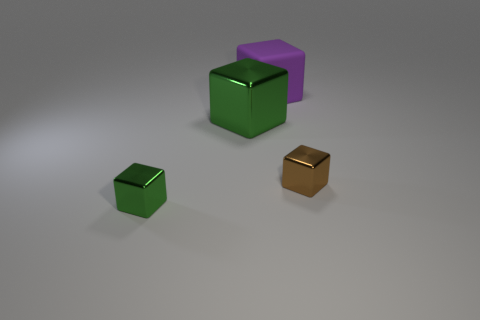Does the big metal object have the same color as the small metal thing left of the purple rubber object?
Ensure brevity in your answer.  Yes. What color is the large metallic thing?
Your answer should be compact. Green. There is a large green metallic thing behind the cube in front of the tiny metal cube right of the large green thing; what is its shape?
Offer a terse response. Cube. What number of other objects are the same color as the big matte object?
Provide a short and direct response. 0. Are there more green objects behind the small green cube than small brown metal cubes that are behind the small brown thing?
Ensure brevity in your answer.  Yes. There is a brown block; are there any things in front of it?
Your answer should be compact. Yes. The cube that is on the right side of the large shiny block and on the left side of the tiny brown shiny cube is made of what material?
Your answer should be compact. Rubber. There is a big matte thing that is the same shape as the big green metallic object; what color is it?
Offer a terse response. Purple. Are there any metal things that are right of the metallic cube that is in front of the brown cube?
Make the answer very short. Yes. What size is the purple matte cube?
Give a very brief answer. Large. 